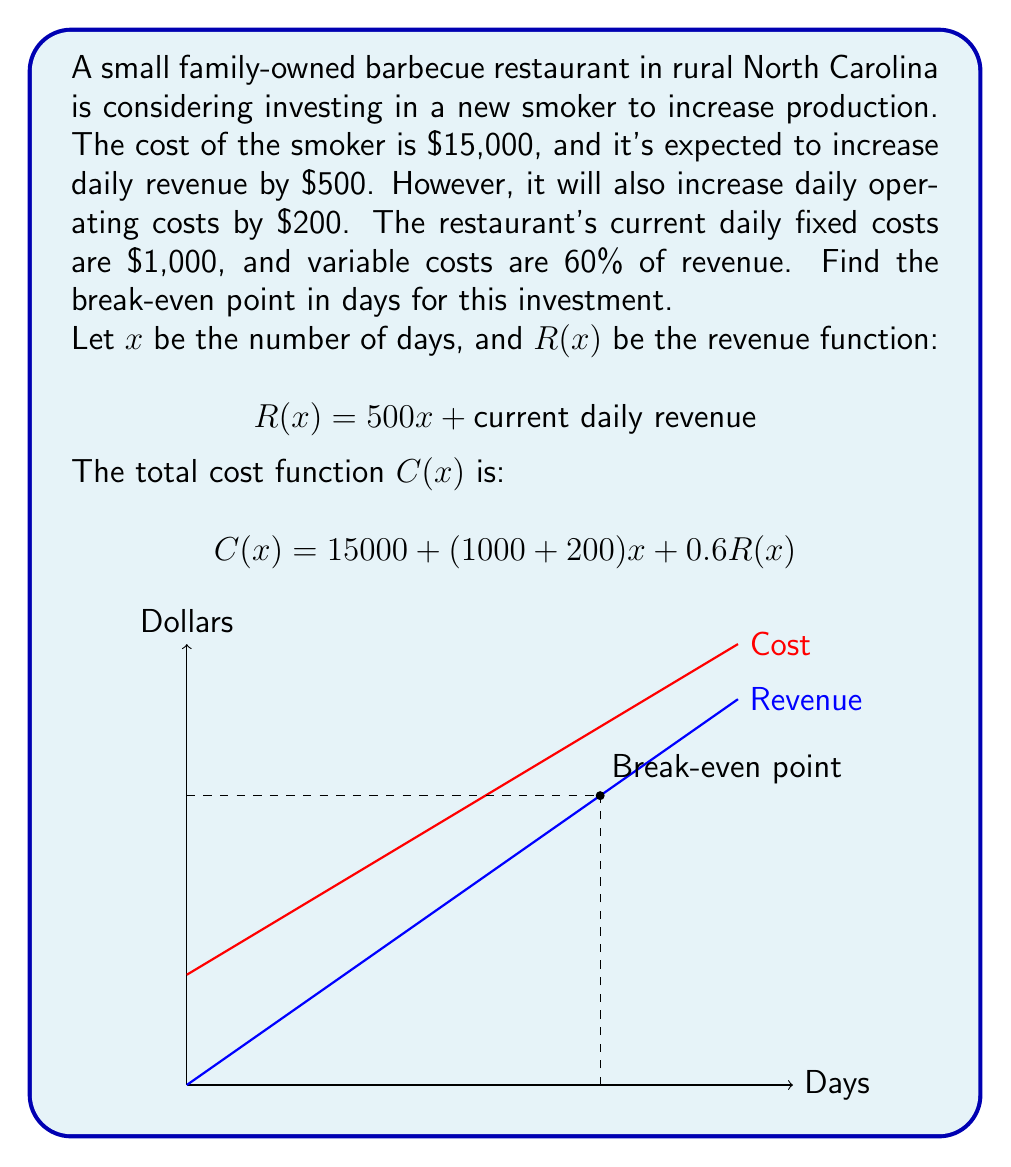Give your solution to this math problem. Let's approach this step-by-step:

1) First, we need to set up the break-even equation:
   Revenue = Total Costs
   
   $$R(x) = C(x)$$

2) Expand this equation:
   
   $$500x + \text{current daily revenue} = 15000 + 1200x + 0.6(500x + \text{current daily revenue})$$

3) The current daily revenue cancels out on both sides:
   
   $$500x = 15000 + 1200x + 300x$$

4) Simplify:
   
   $$500x = 15000 + 1500x$$

5) Subtract 500x from both sides:
   
   $$0 = 15000 + 1000x$$

6) Subtract 15000 from both sides:
   
   $$-15000 = 1000x$$

7) Divide both sides by 1000:
   
   $$-15 = x$$

8) The negative result doesn't make sense in this context, so we take the absolute value:
   
   $$x = 15$$

Therefore, it will take 15 days for the investment to break even.
Answer: 15 days 